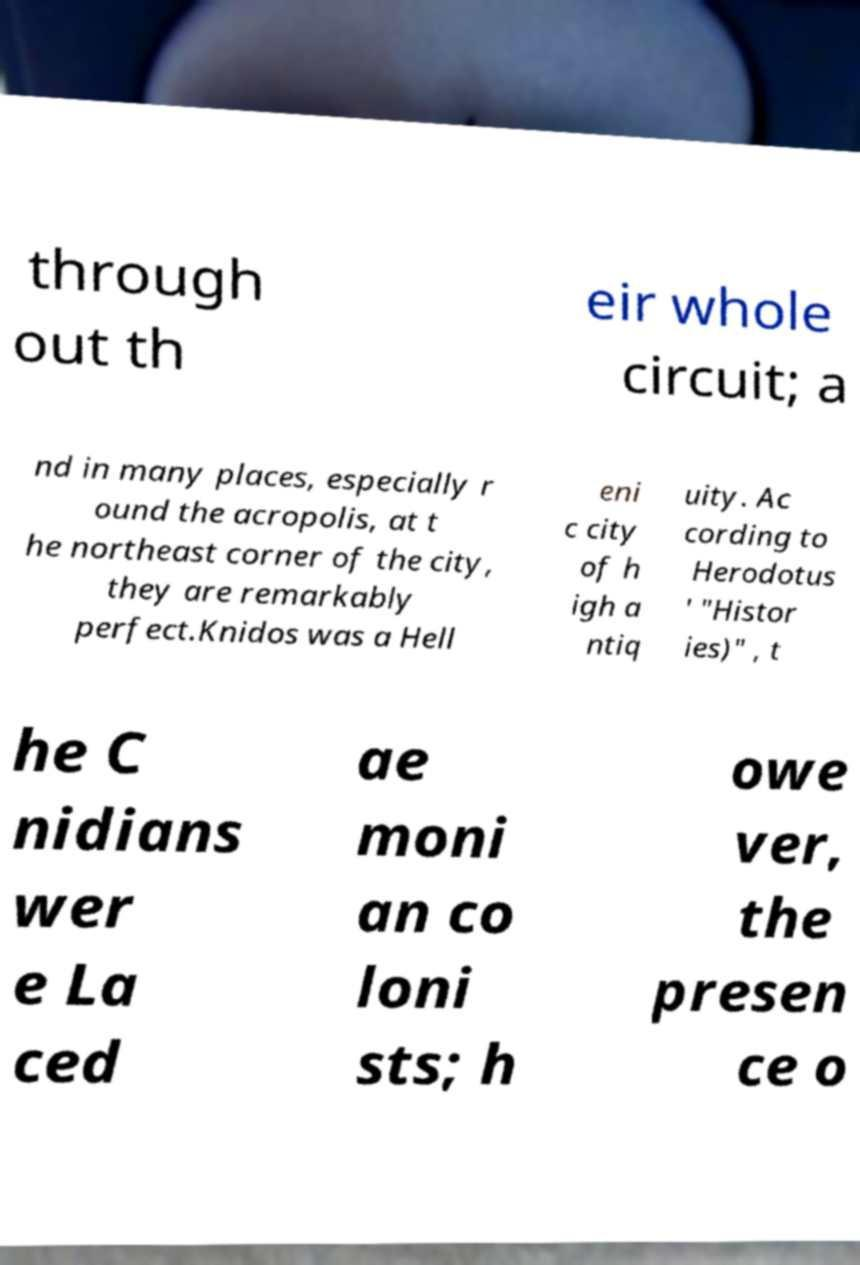There's text embedded in this image that I need extracted. Can you transcribe it verbatim? through out th eir whole circuit; a nd in many places, especially r ound the acropolis, at t he northeast corner of the city, they are remarkably perfect.Knidos was a Hell eni c city of h igh a ntiq uity. Ac cording to Herodotus ' "Histor ies)" , t he C nidians wer e La ced ae moni an co loni sts; h owe ver, the presen ce o 